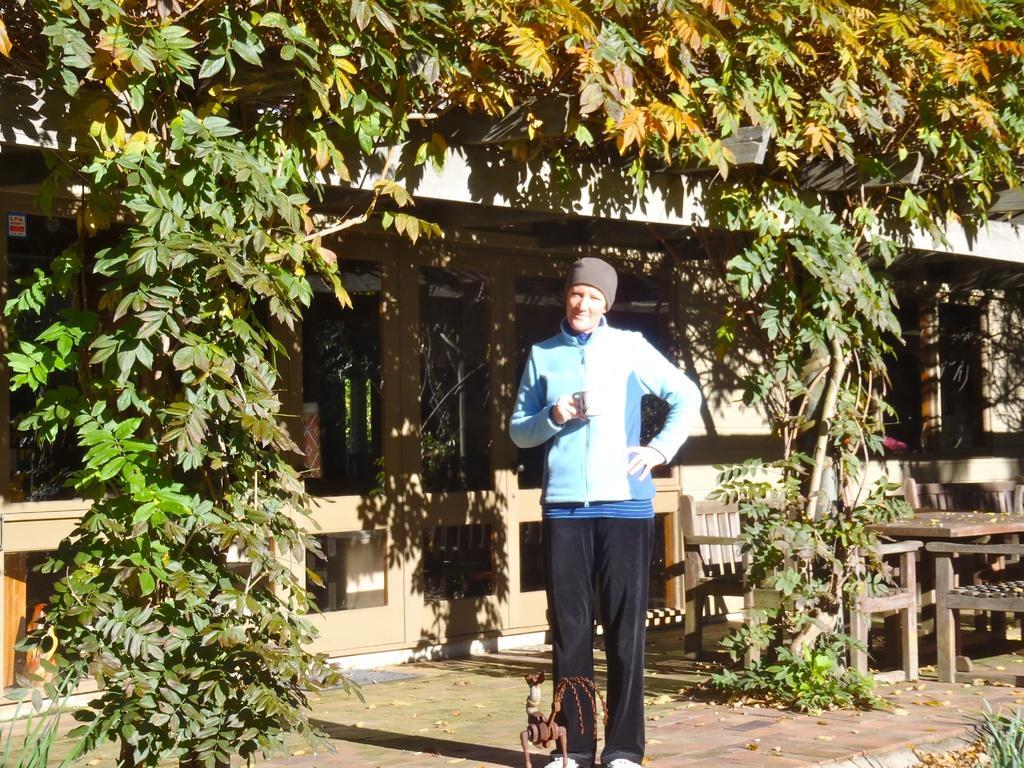How would you summarize this image in a sentence or two? In the picture we can see a person standing on the path holding a cup and behind the person we can see the house near it we can see the plants and a table and chairs. 